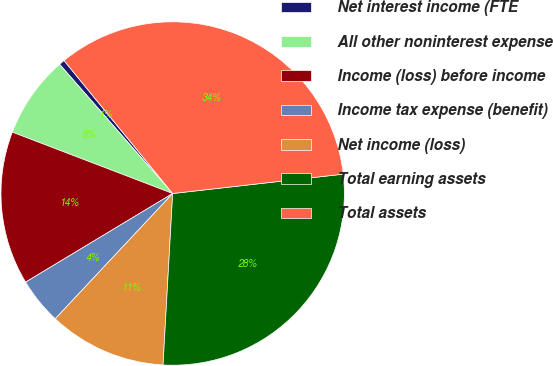<chart> <loc_0><loc_0><loc_500><loc_500><pie_chart><fcel>Net interest income (FTE<fcel>All other noninterest expense<fcel>Income (loss) before income<fcel>Income tax expense (benefit)<fcel>Net income (loss)<fcel>Total earning assets<fcel>Total assets<nl><fcel>0.54%<fcel>7.74%<fcel>14.45%<fcel>4.38%<fcel>11.09%<fcel>27.69%<fcel>34.1%<nl></chart> 